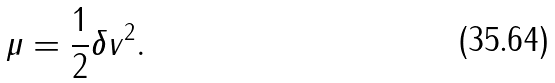<formula> <loc_0><loc_0><loc_500><loc_500>\mu = \frac { 1 } { 2 } \delta v ^ { 2 } .</formula> 